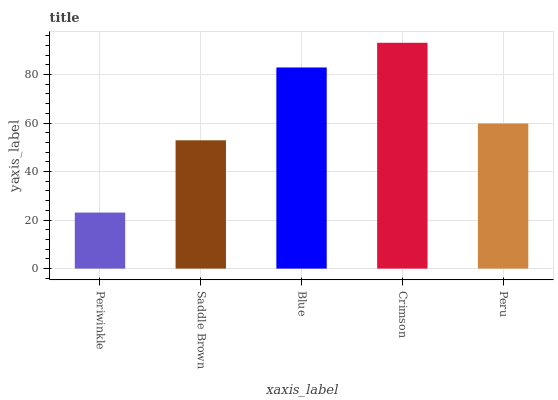Is Periwinkle the minimum?
Answer yes or no. Yes. Is Crimson the maximum?
Answer yes or no. Yes. Is Saddle Brown the minimum?
Answer yes or no. No. Is Saddle Brown the maximum?
Answer yes or no. No. Is Saddle Brown greater than Periwinkle?
Answer yes or no. Yes. Is Periwinkle less than Saddle Brown?
Answer yes or no. Yes. Is Periwinkle greater than Saddle Brown?
Answer yes or no. No. Is Saddle Brown less than Periwinkle?
Answer yes or no. No. Is Peru the high median?
Answer yes or no. Yes. Is Peru the low median?
Answer yes or no. Yes. Is Blue the high median?
Answer yes or no. No. Is Periwinkle the low median?
Answer yes or no. No. 